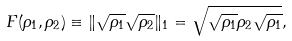<formula> <loc_0><loc_0><loc_500><loc_500>F ( \rho _ { 1 } , \rho _ { 2 } ) \equiv \| \sqrt { \rho _ { 1 } } \sqrt { \rho _ { 2 } } \| _ { 1 } = \sqrt { \sqrt { \rho _ { 1 } } \rho _ { 2 } \sqrt { \rho _ { 1 } } } ,</formula> 